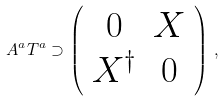<formula> <loc_0><loc_0><loc_500><loc_500>A ^ { a } T ^ { a } \supset \left ( \begin{array} { c c } { 0 } & X \\ X ^ { \dagger } & 0 \end{array} \right ) \, ,</formula> 